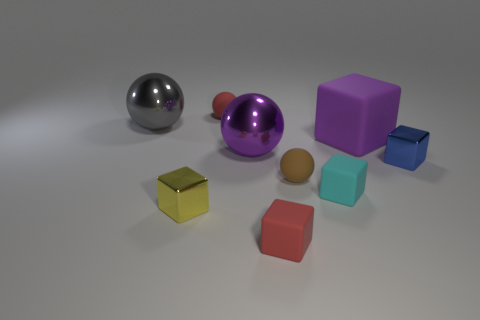There is a red rubber thing behind the metallic thing behind the big purple shiny object; what size is it?
Offer a terse response. Small. What number of objects are either tiny cyan matte cubes or metal cubes that are behind the tiny cyan thing?
Ensure brevity in your answer.  2. There is a small shiny thing that is left of the tiny blue metallic cube; is it the same shape as the purple matte object?
Your response must be concise. Yes. There is a large metallic ball that is on the left side of the tiny red object that is behind the gray thing; what number of small matte spheres are right of it?
Your response must be concise. 2. Are there any other things that have the same shape as the tiny blue object?
Keep it short and to the point. Yes. How many objects are tiny green rubber blocks or blue metallic cubes?
Offer a terse response. 1. There is a large purple matte object; is its shape the same as the small red matte object in front of the red rubber sphere?
Your answer should be very brief. Yes. The tiny brown rubber object that is in front of the blue metallic cube has what shape?
Your answer should be very brief. Sphere. Does the cyan thing have the same shape as the small yellow object?
Keep it short and to the point. Yes. The other metallic thing that is the same shape as the tiny blue thing is what size?
Your answer should be very brief. Small. 